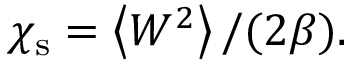<formula> <loc_0><loc_0><loc_500><loc_500>\chi _ { s } = \left < W ^ { 2 } \right > / ( 2 \beta ) .</formula> 